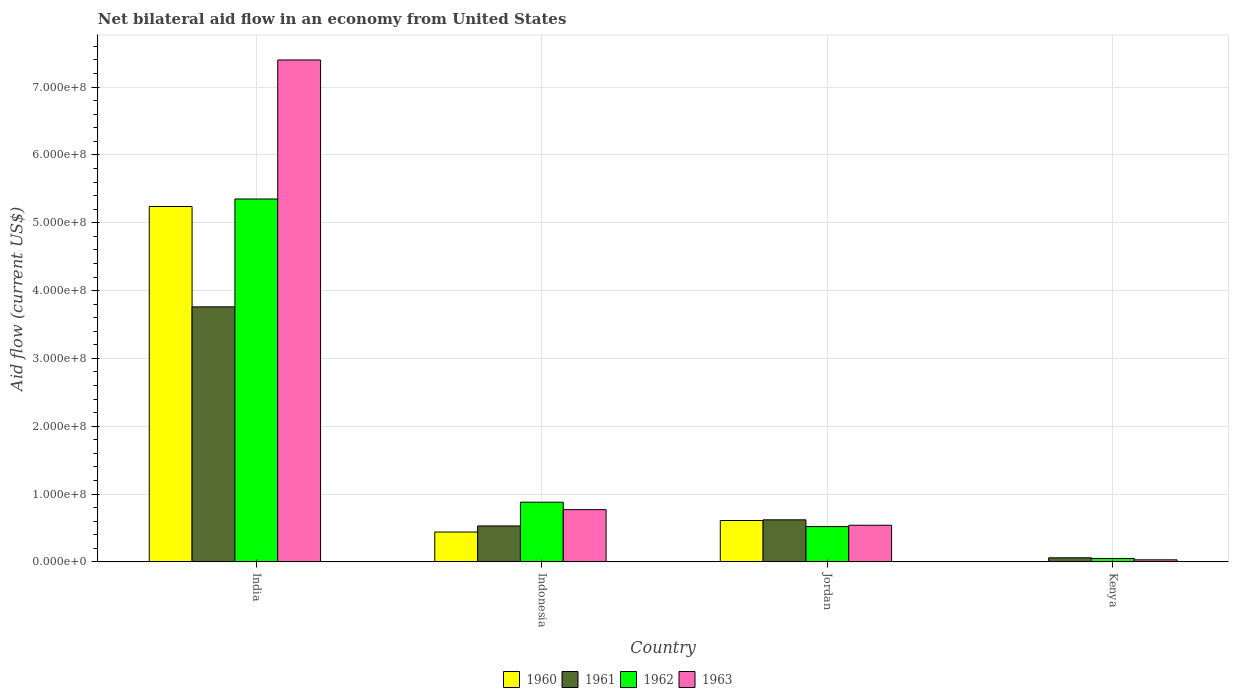Are the number of bars per tick equal to the number of legend labels?
Ensure brevity in your answer.  Yes. Are the number of bars on each tick of the X-axis equal?
Your response must be concise. Yes. What is the label of the 2nd group of bars from the left?
Make the answer very short. Indonesia. In how many cases, is the number of bars for a given country not equal to the number of legend labels?
Your answer should be compact. 0. Across all countries, what is the maximum net bilateral aid flow in 1960?
Offer a very short reply. 5.24e+08. Across all countries, what is the minimum net bilateral aid flow in 1961?
Your answer should be compact. 6.00e+06. In which country was the net bilateral aid flow in 1962 maximum?
Your response must be concise. India. In which country was the net bilateral aid flow in 1960 minimum?
Give a very brief answer. Kenya. What is the total net bilateral aid flow in 1963 in the graph?
Give a very brief answer. 8.74e+08. What is the difference between the net bilateral aid flow in 1961 in India and that in Kenya?
Provide a succinct answer. 3.70e+08. What is the difference between the net bilateral aid flow in 1962 in Kenya and the net bilateral aid flow in 1961 in Indonesia?
Offer a terse response. -4.80e+07. What is the average net bilateral aid flow in 1961 per country?
Your answer should be very brief. 1.24e+08. What is the difference between the net bilateral aid flow of/in 1960 and net bilateral aid flow of/in 1963 in Indonesia?
Your answer should be very brief. -3.30e+07. What is the ratio of the net bilateral aid flow in 1961 in India to that in Kenya?
Provide a succinct answer. 62.67. Is the net bilateral aid flow in 1961 in India less than that in Jordan?
Provide a succinct answer. No. What is the difference between the highest and the second highest net bilateral aid flow in 1962?
Give a very brief answer. 4.47e+08. What is the difference between the highest and the lowest net bilateral aid flow in 1960?
Make the answer very short. 5.24e+08. In how many countries, is the net bilateral aid flow in 1962 greater than the average net bilateral aid flow in 1962 taken over all countries?
Make the answer very short. 1. Is the sum of the net bilateral aid flow in 1963 in India and Kenya greater than the maximum net bilateral aid flow in 1960 across all countries?
Give a very brief answer. Yes. Is it the case that in every country, the sum of the net bilateral aid flow in 1963 and net bilateral aid flow in 1962 is greater than the sum of net bilateral aid flow in 1960 and net bilateral aid flow in 1961?
Provide a succinct answer. No. What does the 1st bar from the left in Kenya represents?
Give a very brief answer. 1960. What does the 2nd bar from the right in Kenya represents?
Provide a succinct answer. 1962. Does the graph contain any zero values?
Make the answer very short. No. Does the graph contain grids?
Ensure brevity in your answer.  Yes. How are the legend labels stacked?
Make the answer very short. Horizontal. What is the title of the graph?
Ensure brevity in your answer.  Net bilateral aid flow in an economy from United States. What is the label or title of the Y-axis?
Offer a terse response. Aid flow (current US$). What is the Aid flow (current US$) in 1960 in India?
Your answer should be very brief. 5.24e+08. What is the Aid flow (current US$) in 1961 in India?
Provide a succinct answer. 3.76e+08. What is the Aid flow (current US$) of 1962 in India?
Offer a terse response. 5.35e+08. What is the Aid flow (current US$) of 1963 in India?
Offer a terse response. 7.40e+08. What is the Aid flow (current US$) of 1960 in Indonesia?
Ensure brevity in your answer.  4.40e+07. What is the Aid flow (current US$) of 1961 in Indonesia?
Offer a terse response. 5.30e+07. What is the Aid flow (current US$) in 1962 in Indonesia?
Make the answer very short. 8.80e+07. What is the Aid flow (current US$) in 1963 in Indonesia?
Provide a succinct answer. 7.70e+07. What is the Aid flow (current US$) in 1960 in Jordan?
Ensure brevity in your answer.  6.10e+07. What is the Aid flow (current US$) of 1961 in Jordan?
Offer a very short reply. 6.20e+07. What is the Aid flow (current US$) of 1962 in Jordan?
Your answer should be very brief. 5.20e+07. What is the Aid flow (current US$) of 1963 in Jordan?
Give a very brief answer. 5.40e+07. What is the Aid flow (current US$) of 1960 in Kenya?
Make the answer very short. 4.80e+05. What is the Aid flow (current US$) of 1962 in Kenya?
Keep it short and to the point. 5.00e+06. What is the Aid flow (current US$) of 1963 in Kenya?
Provide a succinct answer. 3.00e+06. Across all countries, what is the maximum Aid flow (current US$) of 1960?
Your answer should be very brief. 5.24e+08. Across all countries, what is the maximum Aid flow (current US$) of 1961?
Provide a short and direct response. 3.76e+08. Across all countries, what is the maximum Aid flow (current US$) in 1962?
Give a very brief answer. 5.35e+08. Across all countries, what is the maximum Aid flow (current US$) in 1963?
Keep it short and to the point. 7.40e+08. Across all countries, what is the minimum Aid flow (current US$) in 1960?
Your answer should be compact. 4.80e+05. Across all countries, what is the minimum Aid flow (current US$) of 1962?
Your response must be concise. 5.00e+06. Across all countries, what is the minimum Aid flow (current US$) of 1963?
Offer a very short reply. 3.00e+06. What is the total Aid flow (current US$) in 1960 in the graph?
Your answer should be very brief. 6.29e+08. What is the total Aid flow (current US$) of 1961 in the graph?
Provide a succinct answer. 4.97e+08. What is the total Aid flow (current US$) in 1962 in the graph?
Keep it short and to the point. 6.80e+08. What is the total Aid flow (current US$) of 1963 in the graph?
Ensure brevity in your answer.  8.74e+08. What is the difference between the Aid flow (current US$) of 1960 in India and that in Indonesia?
Offer a very short reply. 4.80e+08. What is the difference between the Aid flow (current US$) of 1961 in India and that in Indonesia?
Provide a succinct answer. 3.23e+08. What is the difference between the Aid flow (current US$) of 1962 in India and that in Indonesia?
Provide a short and direct response. 4.47e+08. What is the difference between the Aid flow (current US$) in 1963 in India and that in Indonesia?
Your answer should be very brief. 6.63e+08. What is the difference between the Aid flow (current US$) of 1960 in India and that in Jordan?
Keep it short and to the point. 4.63e+08. What is the difference between the Aid flow (current US$) of 1961 in India and that in Jordan?
Keep it short and to the point. 3.14e+08. What is the difference between the Aid flow (current US$) of 1962 in India and that in Jordan?
Your answer should be very brief. 4.83e+08. What is the difference between the Aid flow (current US$) of 1963 in India and that in Jordan?
Provide a succinct answer. 6.86e+08. What is the difference between the Aid flow (current US$) of 1960 in India and that in Kenya?
Ensure brevity in your answer.  5.24e+08. What is the difference between the Aid flow (current US$) of 1961 in India and that in Kenya?
Your answer should be compact. 3.70e+08. What is the difference between the Aid flow (current US$) in 1962 in India and that in Kenya?
Your response must be concise. 5.30e+08. What is the difference between the Aid flow (current US$) of 1963 in India and that in Kenya?
Provide a succinct answer. 7.37e+08. What is the difference between the Aid flow (current US$) in 1960 in Indonesia and that in Jordan?
Offer a terse response. -1.70e+07. What is the difference between the Aid flow (current US$) in 1961 in Indonesia and that in Jordan?
Your answer should be compact. -9.00e+06. What is the difference between the Aid flow (current US$) of 1962 in Indonesia and that in Jordan?
Provide a succinct answer. 3.60e+07. What is the difference between the Aid flow (current US$) in 1963 in Indonesia and that in Jordan?
Provide a short and direct response. 2.30e+07. What is the difference between the Aid flow (current US$) in 1960 in Indonesia and that in Kenya?
Keep it short and to the point. 4.35e+07. What is the difference between the Aid flow (current US$) of 1961 in Indonesia and that in Kenya?
Provide a succinct answer. 4.70e+07. What is the difference between the Aid flow (current US$) in 1962 in Indonesia and that in Kenya?
Your response must be concise. 8.30e+07. What is the difference between the Aid flow (current US$) of 1963 in Indonesia and that in Kenya?
Your answer should be very brief. 7.40e+07. What is the difference between the Aid flow (current US$) in 1960 in Jordan and that in Kenya?
Offer a terse response. 6.05e+07. What is the difference between the Aid flow (current US$) of 1961 in Jordan and that in Kenya?
Offer a terse response. 5.60e+07. What is the difference between the Aid flow (current US$) of 1962 in Jordan and that in Kenya?
Provide a succinct answer. 4.70e+07. What is the difference between the Aid flow (current US$) of 1963 in Jordan and that in Kenya?
Your answer should be very brief. 5.10e+07. What is the difference between the Aid flow (current US$) of 1960 in India and the Aid flow (current US$) of 1961 in Indonesia?
Ensure brevity in your answer.  4.71e+08. What is the difference between the Aid flow (current US$) in 1960 in India and the Aid flow (current US$) in 1962 in Indonesia?
Give a very brief answer. 4.36e+08. What is the difference between the Aid flow (current US$) of 1960 in India and the Aid flow (current US$) of 1963 in Indonesia?
Make the answer very short. 4.47e+08. What is the difference between the Aid flow (current US$) in 1961 in India and the Aid flow (current US$) in 1962 in Indonesia?
Your response must be concise. 2.88e+08. What is the difference between the Aid flow (current US$) in 1961 in India and the Aid flow (current US$) in 1963 in Indonesia?
Make the answer very short. 2.99e+08. What is the difference between the Aid flow (current US$) of 1962 in India and the Aid flow (current US$) of 1963 in Indonesia?
Offer a terse response. 4.58e+08. What is the difference between the Aid flow (current US$) of 1960 in India and the Aid flow (current US$) of 1961 in Jordan?
Your answer should be very brief. 4.62e+08. What is the difference between the Aid flow (current US$) of 1960 in India and the Aid flow (current US$) of 1962 in Jordan?
Keep it short and to the point. 4.72e+08. What is the difference between the Aid flow (current US$) in 1960 in India and the Aid flow (current US$) in 1963 in Jordan?
Ensure brevity in your answer.  4.70e+08. What is the difference between the Aid flow (current US$) in 1961 in India and the Aid flow (current US$) in 1962 in Jordan?
Ensure brevity in your answer.  3.24e+08. What is the difference between the Aid flow (current US$) of 1961 in India and the Aid flow (current US$) of 1963 in Jordan?
Give a very brief answer. 3.22e+08. What is the difference between the Aid flow (current US$) in 1962 in India and the Aid flow (current US$) in 1963 in Jordan?
Provide a short and direct response. 4.81e+08. What is the difference between the Aid flow (current US$) in 1960 in India and the Aid flow (current US$) in 1961 in Kenya?
Ensure brevity in your answer.  5.18e+08. What is the difference between the Aid flow (current US$) in 1960 in India and the Aid flow (current US$) in 1962 in Kenya?
Provide a succinct answer. 5.19e+08. What is the difference between the Aid flow (current US$) in 1960 in India and the Aid flow (current US$) in 1963 in Kenya?
Keep it short and to the point. 5.21e+08. What is the difference between the Aid flow (current US$) in 1961 in India and the Aid flow (current US$) in 1962 in Kenya?
Your answer should be very brief. 3.71e+08. What is the difference between the Aid flow (current US$) of 1961 in India and the Aid flow (current US$) of 1963 in Kenya?
Keep it short and to the point. 3.73e+08. What is the difference between the Aid flow (current US$) in 1962 in India and the Aid flow (current US$) in 1963 in Kenya?
Your answer should be very brief. 5.32e+08. What is the difference between the Aid flow (current US$) of 1960 in Indonesia and the Aid flow (current US$) of 1961 in Jordan?
Keep it short and to the point. -1.80e+07. What is the difference between the Aid flow (current US$) in 1960 in Indonesia and the Aid flow (current US$) in 1962 in Jordan?
Make the answer very short. -8.00e+06. What is the difference between the Aid flow (current US$) in 1960 in Indonesia and the Aid flow (current US$) in 1963 in Jordan?
Provide a short and direct response. -1.00e+07. What is the difference between the Aid flow (current US$) of 1961 in Indonesia and the Aid flow (current US$) of 1962 in Jordan?
Keep it short and to the point. 1.00e+06. What is the difference between the Aid flow (current US$) in 1962 in Indonesia and the Aid flow (current US$) in 1963 in Jordan?
Ensure brevity in your answer.  3.40e+07. What is the difference between the Aid flow (current US$) in 1960 in Indonesia and the Aid flow (current US$) in 1961 in Kenya?
Make the answer very short. 3.80e+07. What is the difference between the Aid flow (current US$) in 1960 in Indonesia and the Aid flow (current US$) in 1962 in Kenya?
Keep it short and to the point. 3.90e+07. What is the difference between the Aid flow (current US$) of 1960 in Indonesia and the Aid flow (current US$) of 1963 in Kenya?
Make the answer very short. 4.10e+07. What is the difference between the Aid flow (current US$) in 1961 in Indonesia and the Aid flow (current US$) in 1962 in Kenya?
Make the answer very short. 4.80e+07. What is the difference between the Aid flow (current US$) in 1962 in Indonesia and the Aid flow (current US$) in 1963 in Kenya?
Keep it short and to the point. 8.50e+07. What is the difference between the Aid flow (current US$) of 1960 in Jordan and the Aid flow (current US$) of 1961 in Kenya?
Your answer should be very brief. 5.50e+07. What is the difference between the Aid flow (current US$) of 1960 in Jordan and the Aid flow (current US$) of 1962 in Kenya?
Give a very brief answer. 5.60e+07. What is the difference between the Aid flow (current US$) of 1960 in Jordan and the Aid flow (current US$) of 1963 in Kenya?
Offer a terse response. 5.80e+07. What is the difference between the Aid flow (current US$) of 1961 in Jordan and the Aid flow (current US$) of 1962 in Kenya?
Provide a succinct answer. 5.70e+07. What is the difference between the Aid flow (current US$) of 1961 in Jordan and the Aid flow (current US$) of 1963 in Kenya?
Your answer should be compact. 5.90e+07. What is the difference between the Aid flow (current US$) of 1962 in Jordan and the Aid flow (current US$) of 1963 in Kenya?
Your answer should be very brief. 4.90e+07. What is the average Aid flow (current US$) in 1960 per country?
Your response must be concise. 1.57e+08. What is the average Aid flow (current US$) of 1961 per country?
Your answer should be very brief. 1.24e+08. What is the average Aid flow (current US$) in 1962 per country?
Keep it short and to the point. 1.70e+08. What is the average Aid flow (current US$) in 1963 per country?
Provide a succinct answer. 2.18e+08. What is the difference between the Aid flow (current US$) in 1960 and Aid flow (current US$) in 1961 in India?
Your response must be concise. 1.48e+08. What is the difference between the Aid flow (current US$) in 1960 and Aid flow (current US$) in 1962 in India?
Your response must be concise. -1.10e+07. What is the difference between the Aid flow (current US$) in 1960 and Aid flow (current US$) in 1963 in India?
Your answer should be compact. -2.16e+08. What is the difference between the Aid flow (current US$) of 1961 and Aid flow (current US$) of 1962 in India?
Provide a succinct answer. -1.59e+08. What is the difference between the Aid flow (current US$) in 1961 and Aid flow (current US$) in 1963 in India?
Provide a succinct answer. -3.64e+08. What is the difference between the Aid flow (current US$) in 1962 and Aid flow (current US$) in 1963 in India?
Provide a short and direct response. -2.05e+08. What is the difference between the Aid flow (current US$) in 1960 and Aid flow (current US$) in 1961 in Indonesia?
Make the answer very short. -9.00e+06. What is the difference between the Aid flow (current US$) of 1960 and Aid flow (current US$) of 1962 in Indonesia?
Provide a short and direct response. -4.40e+07. What is the difference between the Aid flow (current US$) of 1960 and Aid flow (current US$) of 1963 in Indonesia?
Provide a short and direct response. -3.30e+07. What is the difference between the Aid flow (current US$) in 1961 and Aid flow (current US$) in 1962 in Indonesia?
Your answer should be very brief. -3.50e+07. What is the difference between the Aid flow (current US$) in 1961 and Aid flow (current US$) in 1963 in Indonesia?
Your answer should be very brief. -2.40e+07. What is the difference between the Aid flow (current US$) of 1962 and Aid flow (current US$) of 1963 in Indonesia?
Keep it short and to the point. 1.10e+07. What is the difference between the Aid flow (current US$) of 1960 and Aid flow (current US$) of 1961 in Jordan?
Your answer should be compact. -1.00e+06. What is the difference between the Aid flow (current US$) of 1960 and Aid flow (current US$) of 1962 in Jordan?
Provide a succinct answer. 9.00e+06. What is the difference between the Aid flow (current US$) of 1960 and Aid flow (current US$) of 1963 in Jordan?
Provide a short and direct response. 7.00e+06. What is the difference between the Aid flow (current US$) of 1961 and Aid flow (current US$) of 1962 in Jordan?
Offer a very short reply. 1.00e+07. What is the difference between the Aid flow (current US$) of 1960 and Aid flow (current US$) of 1961 in Kenya?
Keep it short and to the point. -5.52e+06. What is the difference between the Aid flow (current US$) of 1960 and Aid flow (current US$) of 1962 in Kenya?
Provide a succinct answer. -4.52e+06. What is the difference between the Aid flow (current US$) of 1960 and Aid flow (current US$) of 1963 in Kenya?
Provide a succinct answer. -2.52e+06. What is the difference between the Aid flow (current US$) of 1961 and Aid flow (current US$) of 1962 in Kenya?
Provide a succinct answer. 1.00e+06. What is the ratio of the Aid flow (current US$) of 1960 in India to that in Indonesia?
Provide a succinct answer. 11.91. What is the ratio of the Aid flow (current US$) in 1961 in India to that in Indonesia?
Give a very brief answer. 7.09. What is the ratio of the Aid flow (current US$) in 1962 in India to that in Indonesia?
Make the answer very short. 6.08. What is the ratio of the Aid flow (current US$) in 1963 in India to that in Indonesia?
Your answer should be very brief. 9.61. What is the ratio of the Aid flow (current US$) in 1960 in India to that in Jordan?
Ensure brevity in your answer.  8.59. What is the ratio of the Aid flow (current US$) of 1961 in India to that in Jordan?
Your response must be concise. 6.06. What is the ratio of the Aid flow (current US$) of 1962 in India to that in Jordan?
Provide a succinct answer. 10.29. What is the ratio of the Aid flow (current US$) of 1963 in India to that in Jordan?
Keep it short and to the point. 13.7. What is the ratio of the Aid flow (current US$) of 1960 in India to that in Kenya?
Offer a very short reply. 1091.67. What is the ratio of the Aid flow (current US$) in 1961 in India to that in Kenya?
Provide a succinct answer. 62.67. What is the ratio of the Aid flow (current US$) of 1962 in India to that in Kenya?
Your response must be concise. 107. What is the ratio of the Aid flow (current US$) in 1963 in India to that in Kenya?
Give a very brief answer. 246.67. What is the ratio of the Aid flow (current US$) in 1960 in Indonesia to that in Jordan?
Your answer should be compact. 0.72. What is the ratio of the Aid flow (current US$) in 1961 in Indonesia to that in Jordan?
Offer a terse response. 0.85. What is the ratio of the Aid flow (current US$) in 1962 in Indonesia to that in Jordan?
Offer a terse response. 1.69. What is the ratio of the Aid flow (current US$) in 1963 in Indonesia to that in Jordan?
Your answer should be compact. 1.43. What is the ratio of the Aid flow (current US$) of 1960 in Indonesia to that in Kenya?
Provide a short and direct response. 91.67. What is the ratio of the Aid flow (current US$) in 1961 in Indonesia to that in Kenya?
Your answer should be compact. 8.83. What is the ratio of the Aid flow (current US$) of 1963 in Indonesia to that in Kenya?
Offer a very short reply. 25.67. What is the ratio of the Aid flow (current US$) of 1960 in Jordan to that in Kenya?
Make the answer very short. 127.08. What is the ratio of the Aid flow (current US$) of 1961 in Jordan to that in Kenya?
Keep it short and to the point. 10.33. What is the ratio of the Aid flow (current US$) in 1962 in Jordan to that in Kenya?
Your answer should be compact. 10.4. What is the difference between the highest and the second highest Aid flow (current US$) in 1960?
Your answer should be compact. 4.63e+08. What is the difference between the highest and the second highest Aid flow (current US$) of 1961?
Make the answer very short. 3.14e+08. What is the difference between the highest and the second highest Aid flow (current US$) in 1962?
Provide a short and direct response. 4.47e+08. What is the difference between the highest and the second highest Aid flow (current US$) in 1963?
Provide a short and direct response. 6.63e+08. What is the difference between the highest and the lowest Aid flow (current US$) of 1960?
Give a very brief answer. 5.24e+08. What is the difference between the highest and the lowest Aid flow (current US$) in 1961?
Provide a short and direct response. 3.70e+08. What is the difference between the highest and the lowest Aid flow (current US$) in 1962?
Keep it short and to the point. 5.30e+08. What is the difference between the highest and the lowest Aid flow (current US$) in 1963?
Offer a terse response. 7.37e+08. 